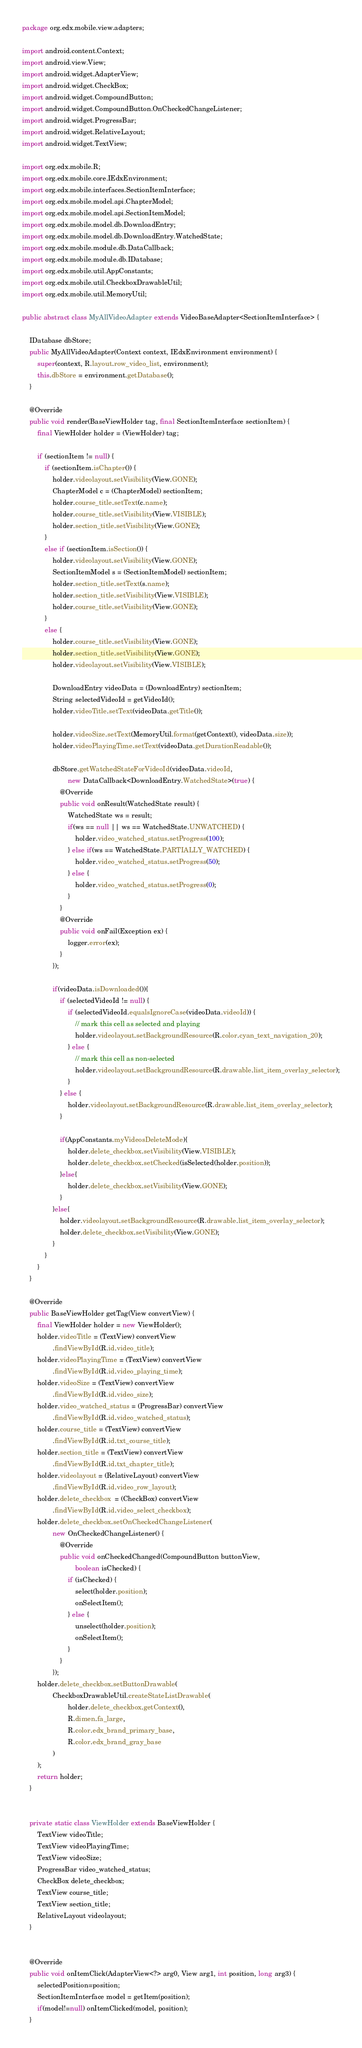Convert code to text. <code><loc_0><loc_0><loc_500><loc_500><_Java_>package org.edx.mobile.view.adapters;

import android.content.Context;
import android.view.View;
import android.widget.AdapterView;
import android.widget.CheckBox;
import android.widget.CompoundButton;
import android.widget.CompoundButton.OnCheckedChangeListener;
import android.widget.ProgressBar;
import android.widget.RelativeLayout;
import android.widget.TextView;

import org.edx.mobile.R;
import org.edx.mobile.core.IEdxEnvironment;
import org.edx.mobile.interfaces.SectionItemInterface;
import org.edx.mobile.model.api.ChapterModel;
import org.edx.mobile.model.api.SectionItemModel;
import org.edx.mobile.model.db.DownloadEntry;
import org.edx.mobile.model.db.DownloadEntry.WatchedState;
import org.edx.mobile.module.db.DataCallback;
import org.edx.mobile.module.db.IDatabase;
import org.edx.mobile.util.AppConstants;
import org.edx.mobile.util.CheckboxDrawableUtil;
import org.edx.mobile.util.MemoryUtil;

public abstract class MyAllVideoAdapter extends VideoBaseAdapter<SectionItemInterface> {

    IDatabase dbStore;
    public MyAllVideoAdapter(Context context, IEdxEnvironment environment) {
        super(context, R.layout.row_video_list, environment);
        this.dbStore = environment.getDatabase();
    }

    @Override
    public void render(BaseViewHolder tag, final SectionItemInterface sectionItem) {
        final ViewHolder holder = (ViewHolder) tag;

        if (sectionItem != null) {
            if (sectionItem.isChapter()) {
                holder.videolayout.setVisibility(View.GONE);
                ChapterModel c = (ChapterModel) sectionItem;
                holder.course_title.setText(c.name);
                holder.course_title.setVisibility(View.VISIBLE);
                holder.section_title.setVisibility(View.GONE);
            }
            else if (sectionItem.isSection()) {
                holder.videolayout.setVisibility(View.GONE);
                SectionItemModel s = (SectionItemModel) sectionItem;
                holder.section_title.setText(s.name);
                holder.section_title.setVisibility(View.VISIBLE);
                holder.course_title.setVisibility(View.GONE);
            }
            else {
                holder.course_title.setVisibility(View.GONE);
                holder.section_title.setVisibility(View.GONE);
                holder.videolayout.setVisibility(View.VISIBLE);

                DownloadEntry videoData = (DownloadEntry) sectionItem;
                String selectedVideoId = getVideoId();
                holder.videoTitle.setText(videoData.getTitle());

                holder.videoSize.setText(MemoryUtil.format(getContext(), videoData.size));
                holder.videoPlayingTime.setText(videoData.getDurationReadable());

                dbStore.getWatchedStateForVideoId(videoData.videoId,
                        new DataCallback<DownloadEntry.WatchedState>(true) {
                    @Override
                    public void onResult(WatchedState result) {
                        WatchedState ws = result;
                        if(ws == null || ws == WatchedState.UNWATCHED) {
                            holder.video_watched_status.setProgress(100);
                        } else if(ws == WatchedState.PARTIALLY_WATCHED) {
                            holder.video_watched_status.setProgress(50);
                        } else {
                            holder.video_watched_status.setProgress(0);
                        }
                    }
                    @Override
                    public void onFail(Exception ex) {
                        logger.error(ex);
                    }
                });

                if(videoData.isDownloaded()){
                    if (selectedVideoId != null) {
                        if (selectedVideoId.equalsIgnoreCase(videoData.videoId)) {
                            // mark this cell as selected and playing
                            holder.videolayout.setBackgroundResource(R.color.cyan_text_navigation_20);
                        } else {
                            // mark this cell as non-selected
                            holder.videolayout.setBackgroundResource(R.drawable.list_item_overlay_selector);
                        }
                    } else {
                        holder.videolayout.setBackgroundResource(R.drawable.list_item_overlay_selector);
                    }

                    if(AppConstants.myVideosDeleteMode){
                        holder.delete_checkbox.setVisibility(View.VISIBLE);
                        holder.delete_checkbox.setChecked(isSelected(holder.position));
                    }else{
                        holder.delete_checkbox.setVisibility(View.GONE);
                    }
                }else{
                    holder.videolayout.setBackgroundResource(R.drawable.list_item_overlay_selector);
                    holder.delete_checkbox.setVisibility(View.GONE);
                }
            }
        }
    }

    @Override
    public BaseViewHolder getTag(View convertView) {
        final ViewHolder holder = new ViewHolder();
        holder.videoTitle = (TextView) convertView
                .findViewById(R.id.video_title);
        holder.videoPlayingTime = (TextView) convertView
                .findViewById(R.id.video_playing_time);
        holder.videoSize = (TextView) convertView
                .findViewById(R.id.video_size);
        holder.video_watched_status = (ProgressBar) convertView
                .findViewById(R.id.video_watched_status);
        holder.course_title = (TextView) convertView
                .findViewById(R.id.txt_course_title);
        holder.section_title = (TextView) convertView
                .findViewById(R.id.txt_chapter_title);
        holder.videolayout = (RelativeLayout) convertView
                .findViewById(R.id.video_row_layout);
        holder.delete_checkbox  = (CheckBox) convertView
                .findViewById(R.id.video_select_checkbox);
        holder.delete_checkbox.setOnCheckedChangeListener(
                new OnCheckedChangeListener() {
                    @Override
                    public void onCheckedChanged(CompoundButton buttonView,
                            boolean isChecked) {
                        if (isChecked) {
                            select(holder.position);
                            onSelectItem();
                        } else {
                            unselect(holder.position);
                            onSelectItem();
                        }
                    }
                });
        holder.delete_checkbox.setButtonDrawable(
                CheckboxDrawableUtil.createStateListDrawable(
                        holder.delete_checkbox.getContext(),
                        R.dimen.fa_large,
                        R.color.edx_brand_primary_base,
                        R.color.edx_brand_gray_base
                )
        );
        return holder;
    }


    private static class ViewHolder extends BaseViewHolder {
        TextView videoTitle;
        TextView videoPlayingTime;
        TextView videoSize;
        ProgressBar video_watched_status;
        CheckBox delete_checkbox;
        TextView course_title;
        TextView section_title;
        RelativeLayout videolayout;
    }


    @Override
    public void onItemClick(AdapterView<?> arg0, View arg1, int position, long arg3) {
        selectedPosition=position;
        SectionItemInterface model = getItem(position);
        if(model!=null) onItemClicked(model, position);
    }
</code> 